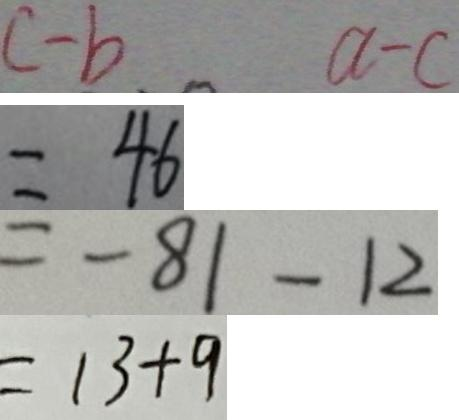<formula> <loc_0><loc_0><loc_500><loc_500>c - b a - c 
 = 4 6 
 = - 8 1 - 1 2 
 = 1 3 + 9</formula> 